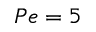<formula> <loc_0><loc_0><loc_500><loc_500>P e = 5</formula> 